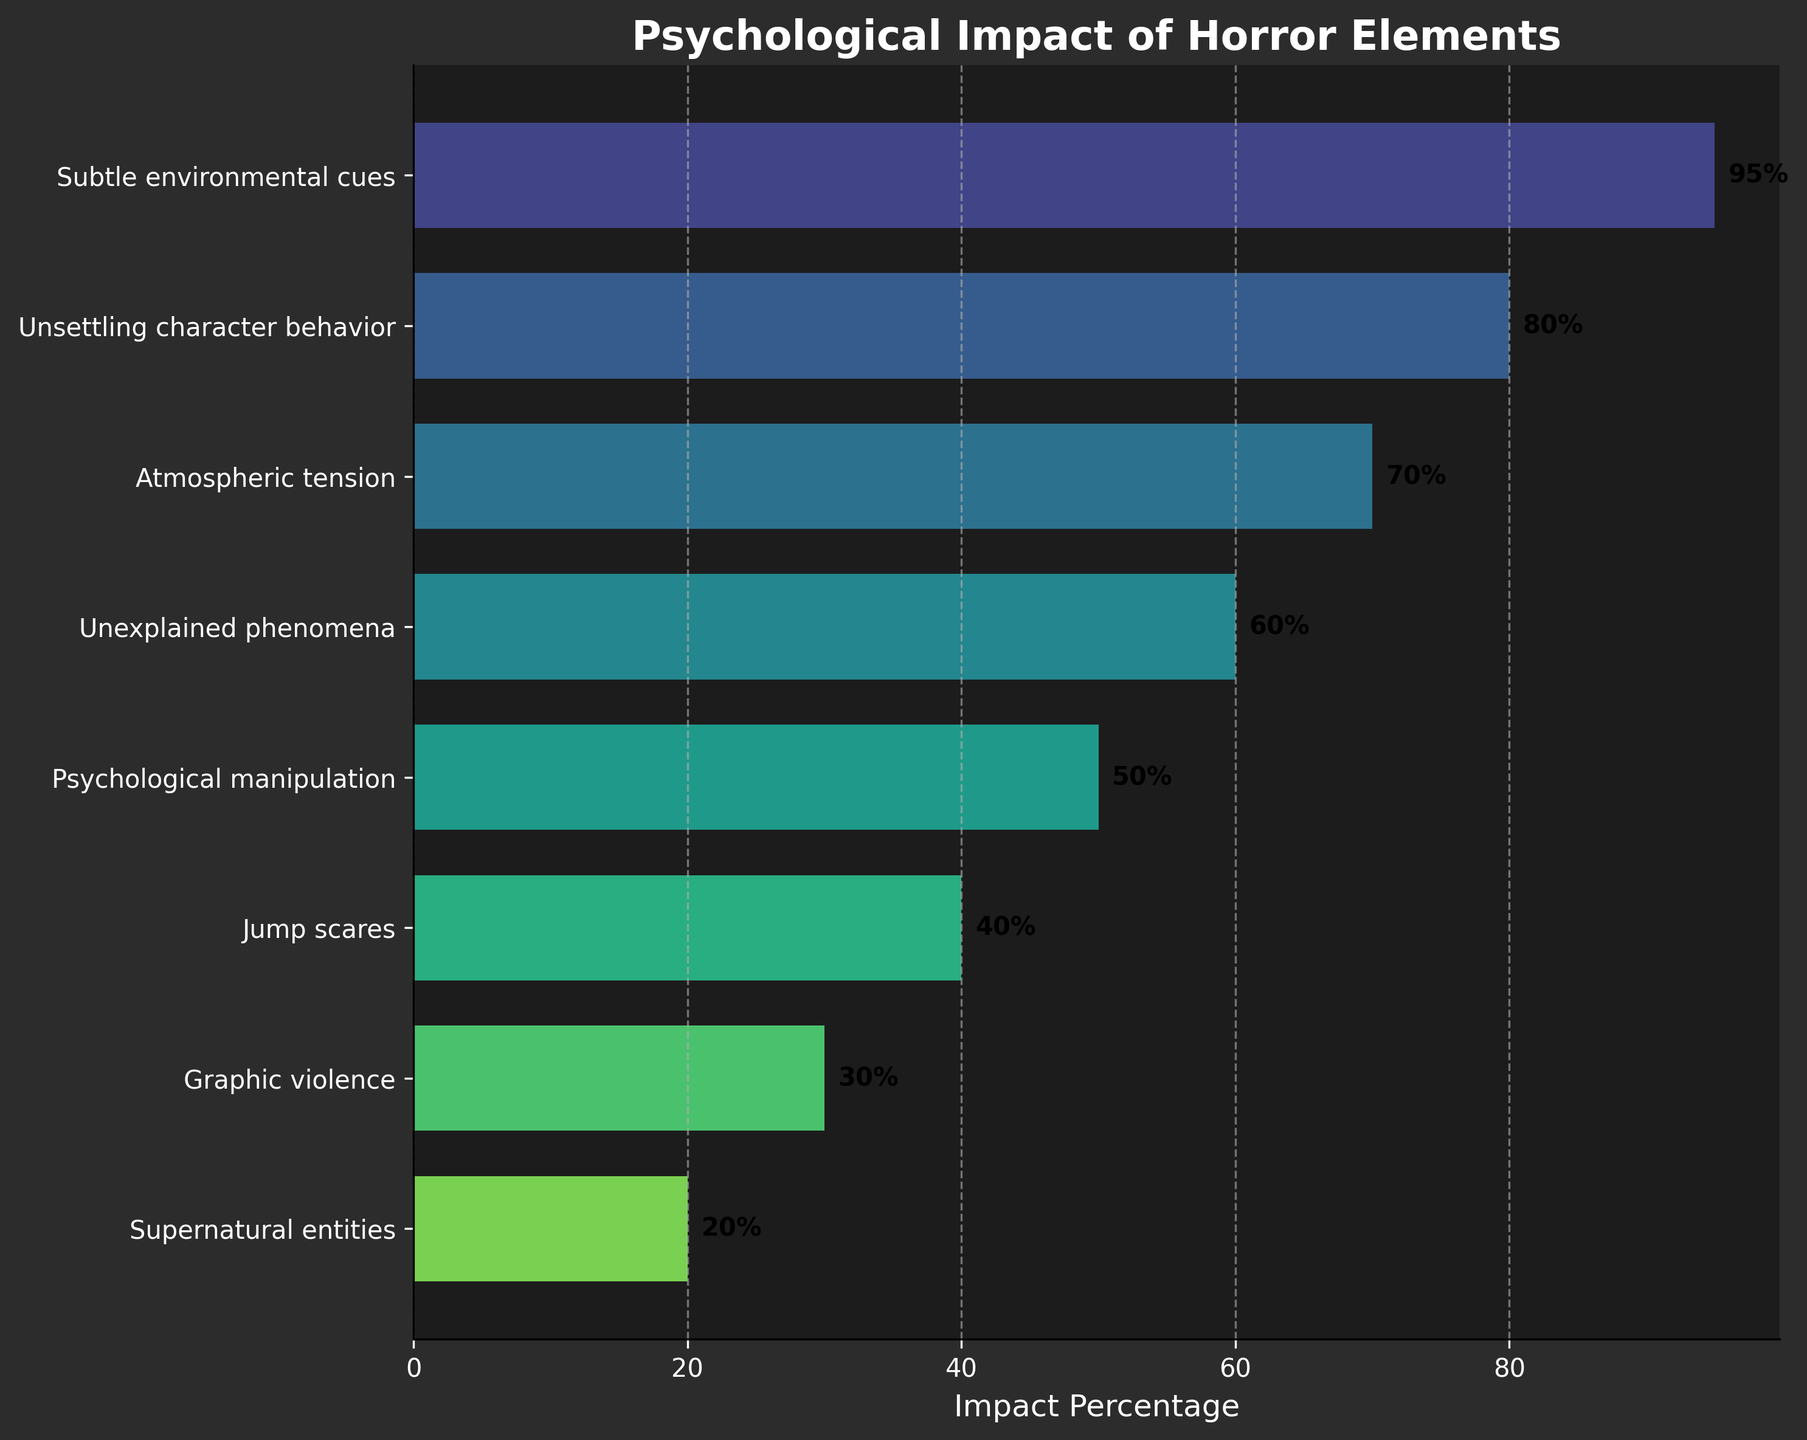What is the title of the figure? The title is located at the top of the figure and is written in a bold, large font. This is often the easiest piece of text to locate and understand.
Answer: Psychological Impact of Horror Elements Which stage has the highest psychological impact? By examining the bar lengths and the percentage labels, the stage with the highest percentage is at the top.
Answer: Subtle environmental cues How many stages are displayed in the figure? Count the number of horizontal bars or the labels on the y-axis to determine the total number of stages.
Answer: 8 What is the percentage difference between "Psychological manipulation" and "Jump scares"? Locate the bars for these two stages and subtract the smaller percentage from the larger one: 50% - 40%.
Answer: 10% Which stage has a higher psychological impact: "Unsettling character behavior" or "Atmospheric tension"? Compare the lengths of the bars or the percentage labels of the two stages: 80% for "Unsettling character behavior" and 70% for "Atmospheric tension."
Answer: Unsettling character behavior What is the median psychological impact percentage among all stages? List all the percentages in order (95, 80, 70, 60, 50, 40, 30, 20) and find the middle value or the average of the two middle values if the number of data points is even. Between 60% and 50%, the median is (60+50)/2.
Answer: 55% Which stages have an impact percentage of 50% or higher? Identify the bars that are 50% or larger and list their labels. These are stages with lengths equal to or greater than the 50% mark.
Answer: Subtle environmental cues, Unsettling character behavior, Atmospheric tension, Unexplained phenomena, Psychological manipulation What is the average psychological impact percentage across all stages? Add all the percentage values and divide by the number of stages: (95+80+70+60+50+40+30+20)/8.
Answer: 55% What is the percentage impact of the least impactful stage? Locate the stage at the bottom of the funnel chart, which has the smallest percentage.
Answer: Supernatural entities Which stages show a decline in impact percentage of more than 20% from the previous stage? Identify pairs of consecutive stages where the percentage drop exceeds 20%. Check the difference in values: (95-80)=15, (80-70)=10, (70-60)=10, (60-50)=10, (50-40)=10, (40-30)=10, (30-20)=10. None of these differences is greater than 20%.
Answer: None 